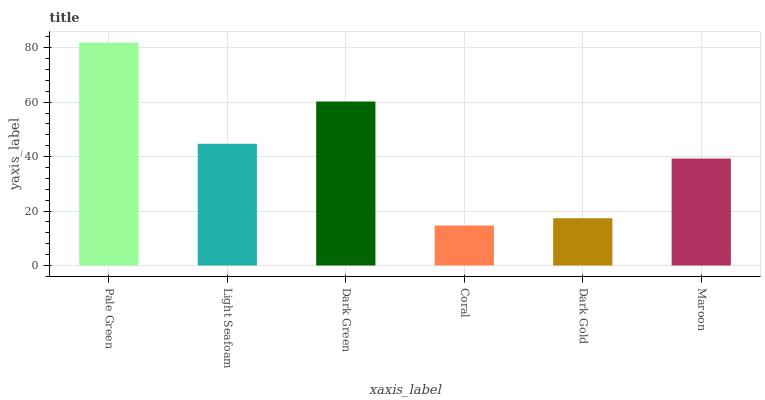Is Coral the minimum?
Answer yes or no. Yes. Is Pale Green the maximum?
Answer yes or no. Yes. Is Light Seafoam the minimum?
Answer yes or no. No. Is Light Seafoam the maximum?
Answer yes or no. No. Is Pale Green greater than Light Seafoam?
Answer yes or no. Yes. Is Light Seafoam less than Pale Green?
Answer yes or no. Yes. Is Light Seafoam greater than Pale Green?
Answer yes or no. No. Is Pale Green less than Light Seafoam?
Answer yes or no. No. Is Light Seafoam the high median?
Answer yes or no. Yes. Is Maroon the low median?
Answer yes or no. Yes. Is Pale Green the high median?
Answer yes or no. No. Is Coral the low median?
Answer yes or no. No. 